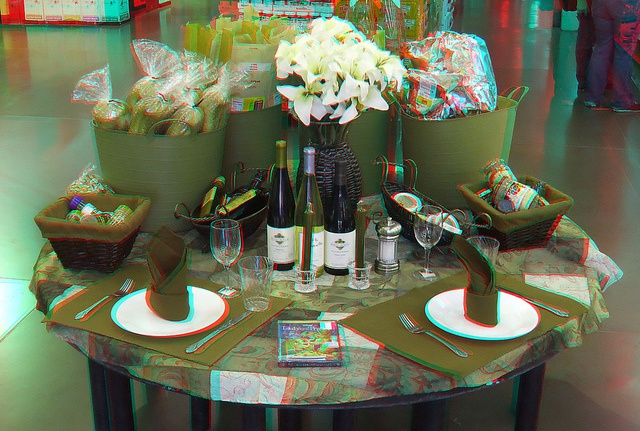Describe the objects in this image and their specific colors. I can see dining table in tan, darkgreen, black, gray, and ivory tones, potted plant in tan, beige, black, khaki, and maroon tones, bowl in tan, black, maroon, teal, and darkgreen tones, book in tan, gray, olive, brown, and teal tones, and bottle in tan, black, lightgray, darkgray, and gray tones in this image. 